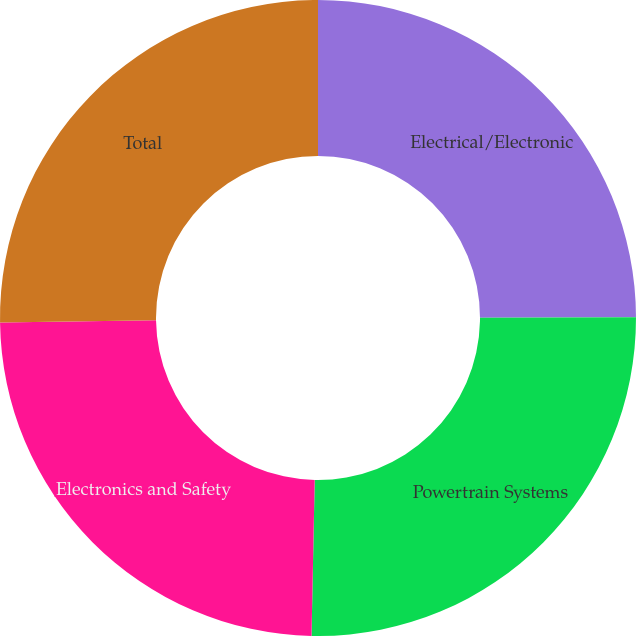Convert chart to OTSL. <chart><loc_0><loc_0><loc_500><loc_500><pie_chart><fcel>Electrical/Electronic<fcel>Powertrain Systems<fcel>Electronics and Safety<fcel>Total<nl><fcel>24.97%<fcel>25.36%<fcel>24.45%<fcel>25.23%<nl></chart> 